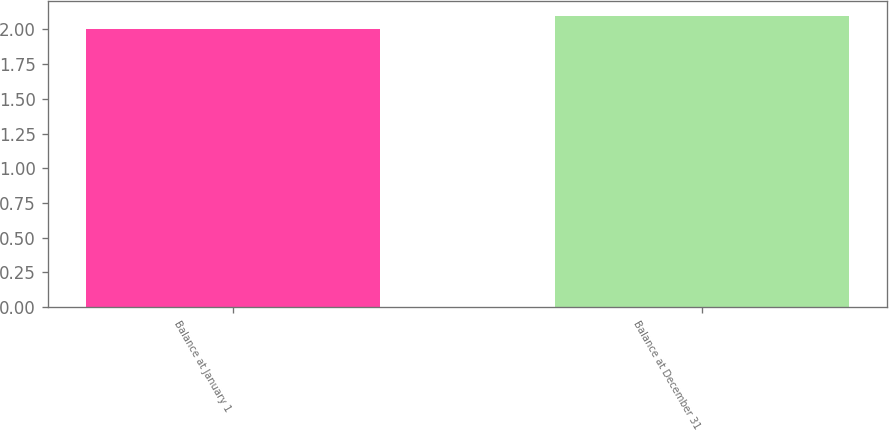Convert chart. <chart><loc_0><loc_0><loc_500><loc_500><bar_chart><fcel>Balance at January 1<fcel>Balance at December 31<nl><fcel>2<fcel>2.1<nl></chart> 